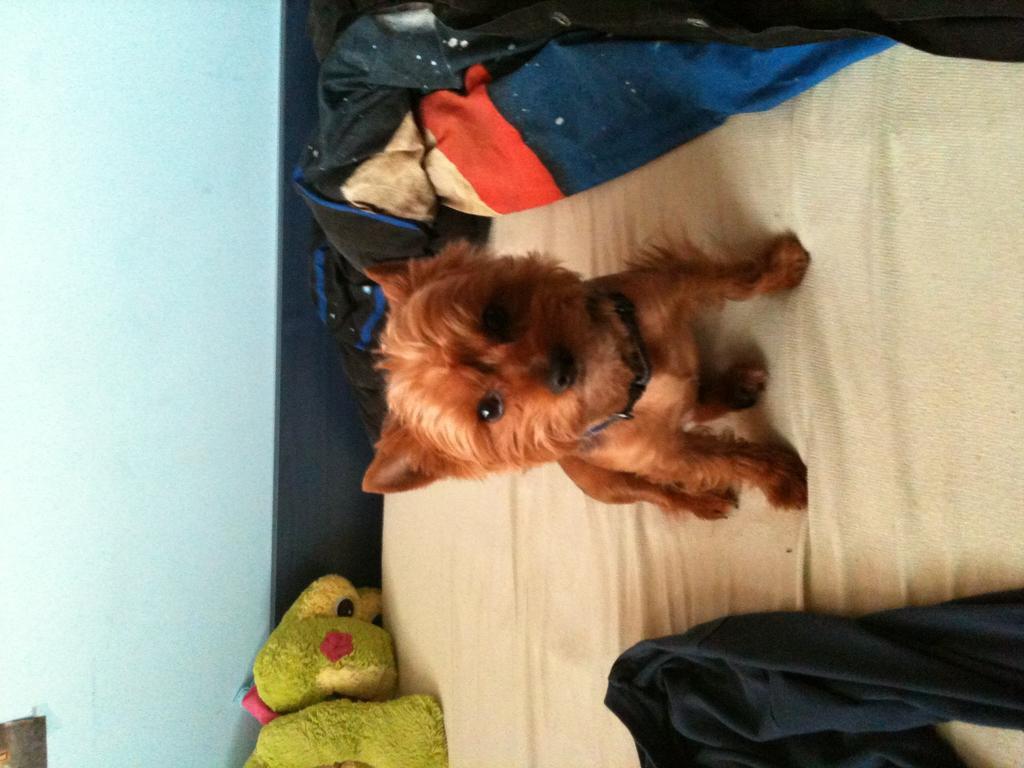Describe this image in one or two sentences. This image is in left direction. Here I can see a dog, toys and few clothes are placed on a bed. The dog is looking at the picture. On the left side there is a wall. 